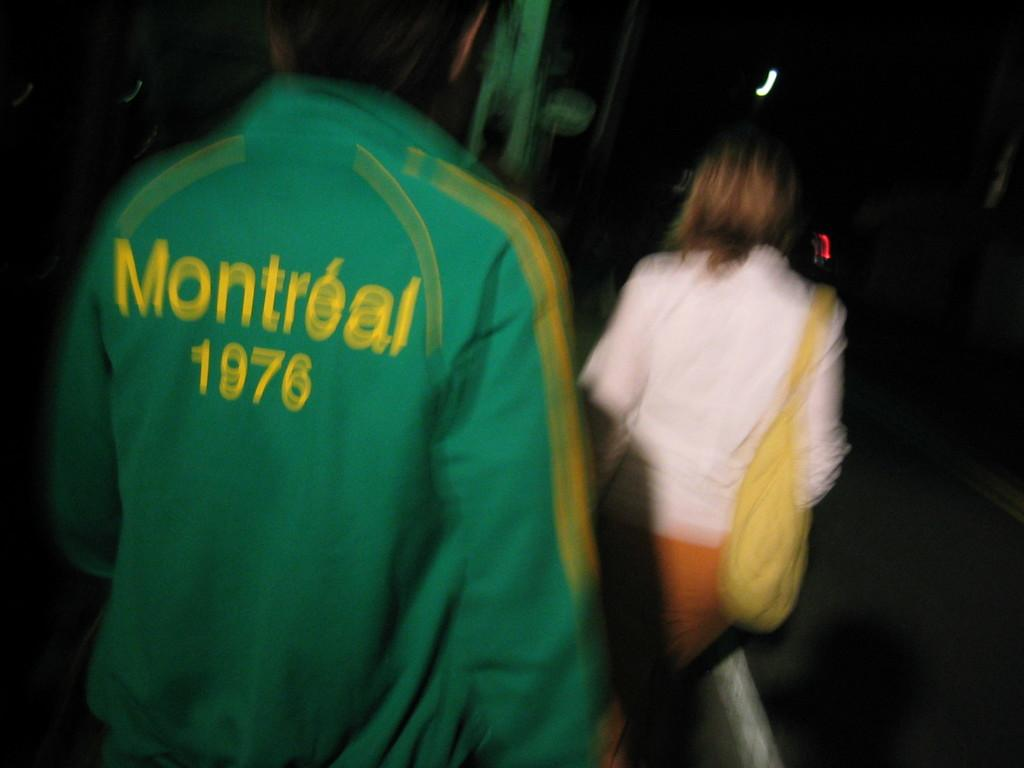<image>
Provide a brief description of the given image. A person wears a jacket with the date 1976 on the back. 